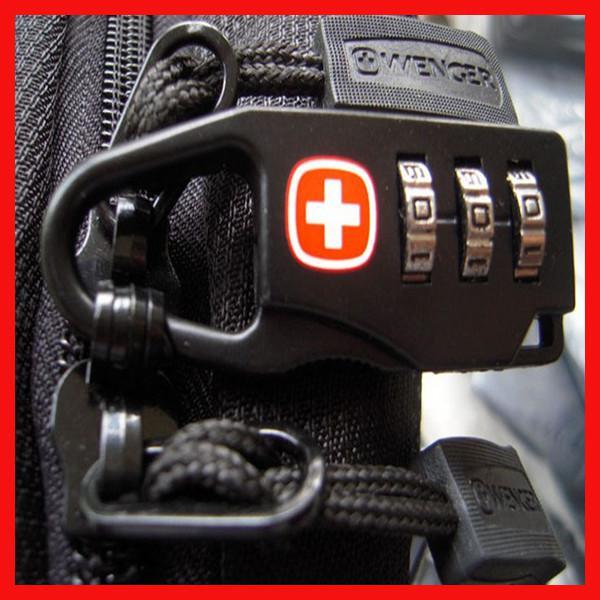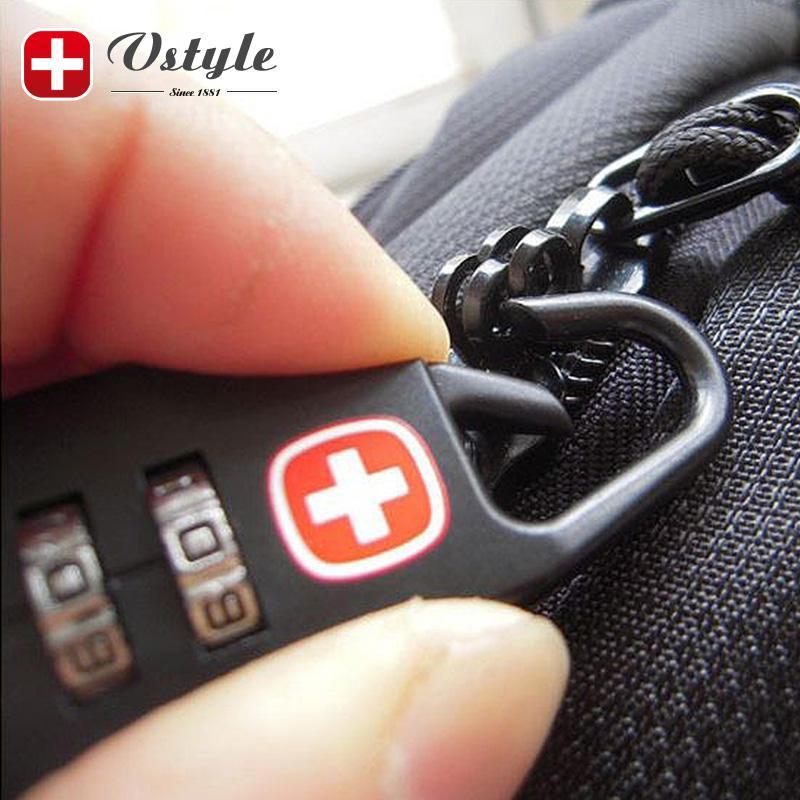The first image is the image on the left, the second image is the image on the right. Assess this claim about the two images: "There are two locks attached to bags.". Correct or not? Answer yes or no. Yes. The first image is the image on the left, the second image is the image on the right. Evaluate the accuracy of this statement regarding the images: "There are two thumbs in on e of the images.". Is it true? Answer yes or no. No. 